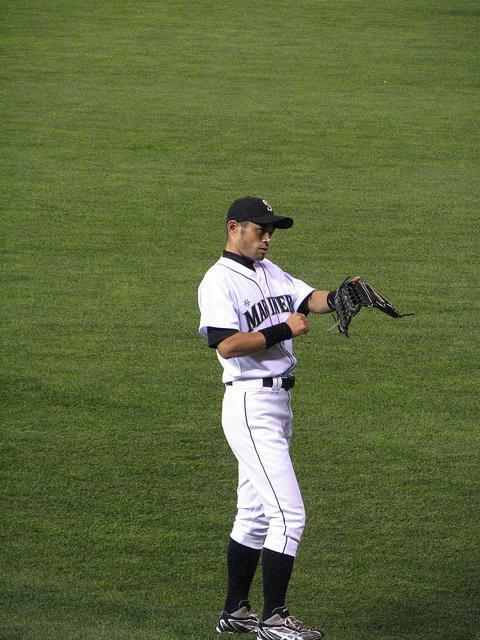How many pieces of pizza are missing?
Give a very brief answer. 0. 